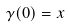<formula> <loc_0><loc_0><loc_500><loc_500>\gamma ( 0 ) = x</formula> 